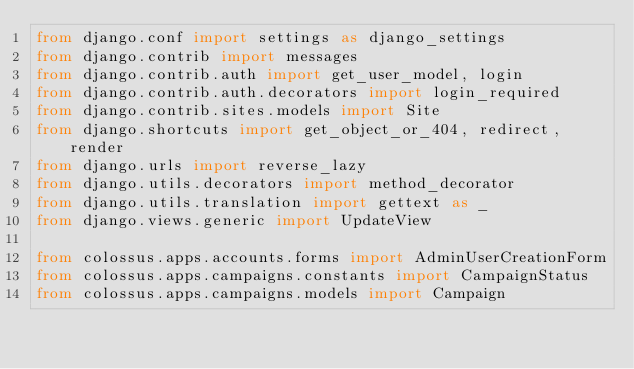Convert code to text. <code><loc_0><loc_0><loc_500><loc_500><_Python_>from django.conf import settings as django_settings
from django.contrib import messages
from django.contrib.auth import get_user_model, login
from django.contrib.auth.decorators import login_required
from django.contrib.sites.models import Site
from django.shortcuts import get_object_or_404, redirect, render
from django.urls import reverse_lazy
from django.utils.decorators import method_decorator
from django.utils.translation import gettext as _
from django.views.generic import UpdateView

from colossus.apps.accounts.forms import AdminUserCreationForm
from colossus.apps.campaigns.constants import CampaignStatus
from colossus.apps.campaigns.models import Campaign</code> 